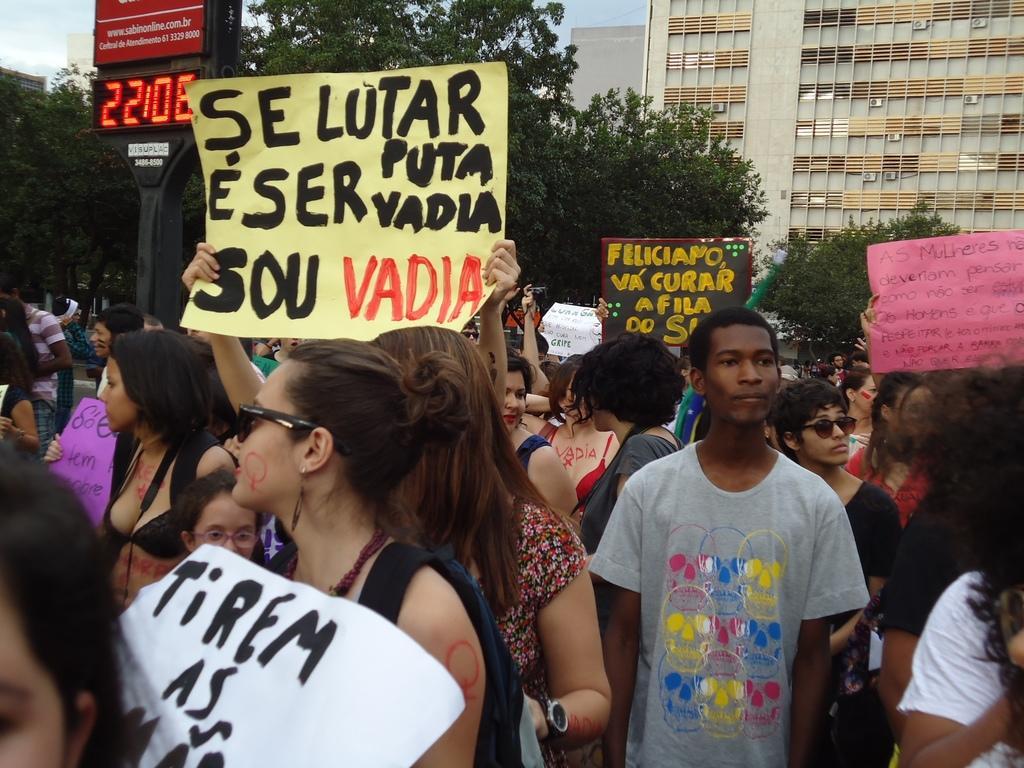How would you summarize this image in a sentence or two? In this image there are some people who are standing and some of them are holding some placards, and in the background there are some trees, buildings and a board. On the board there is some text. 